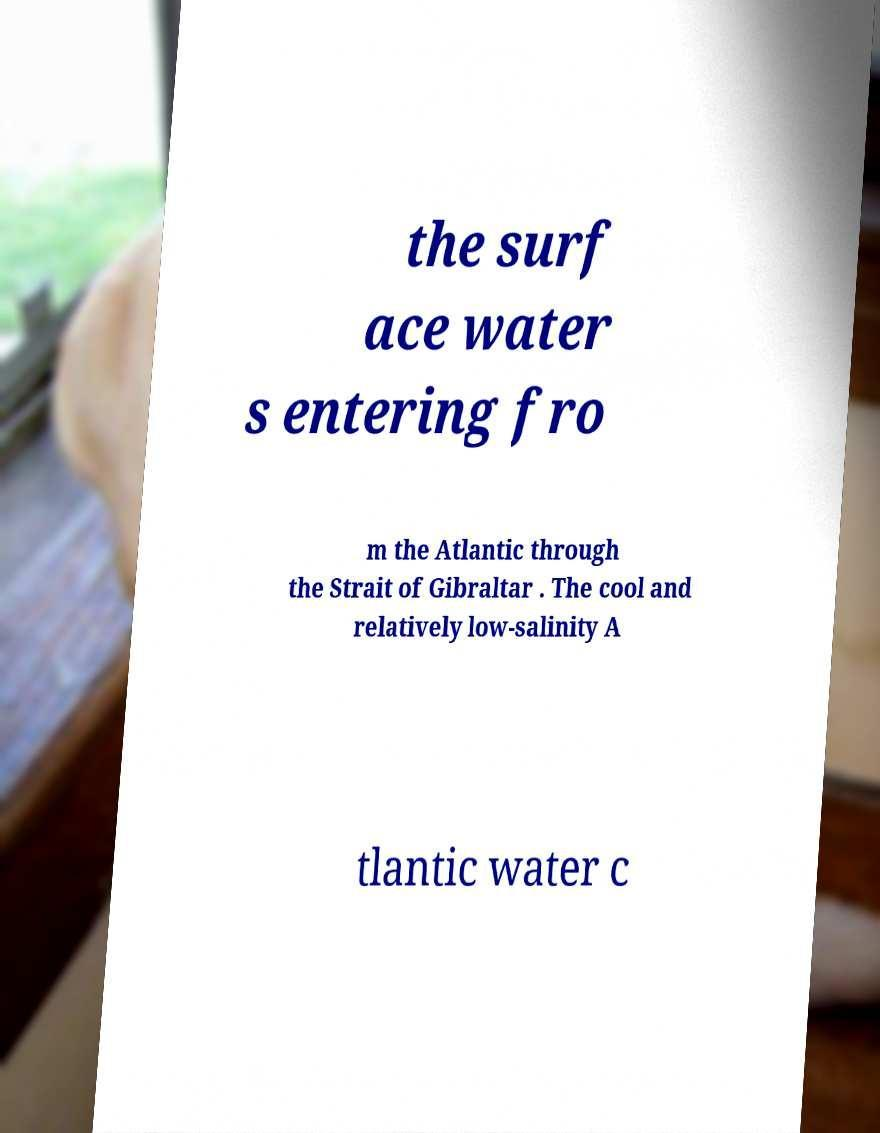Could you assist in decoding the text presented in this image and type it out clearly? the surf ace water s entering fro m the Atlantic through the Strait of Gibraltar . The cool and relatively low-salinity A tlantic water c 